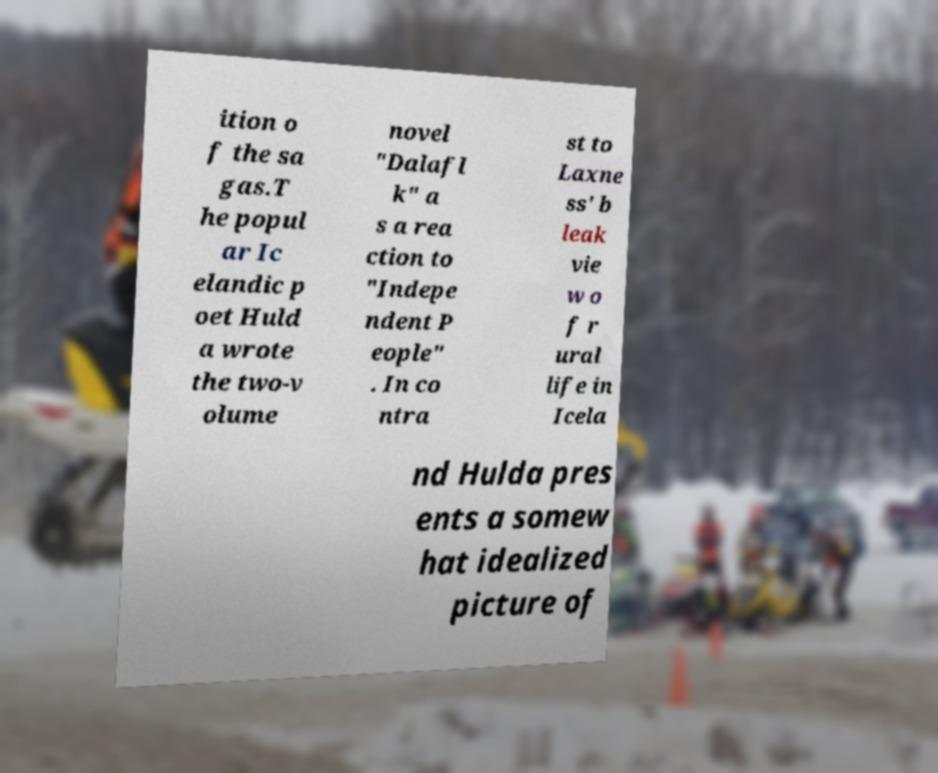Could you extract and type out the text from this image? ition o f the sa gas.T he popul ar Ic elandic p oet Huld a wrote the two-v olume novel "Dalafl k" a s a rea ction to "Indepe ndent P eople" . In co ntra st to Laxne ss' b leak vie w o f r ural life in Icela nd Hulda pres ents a somew hat idealized picture of 